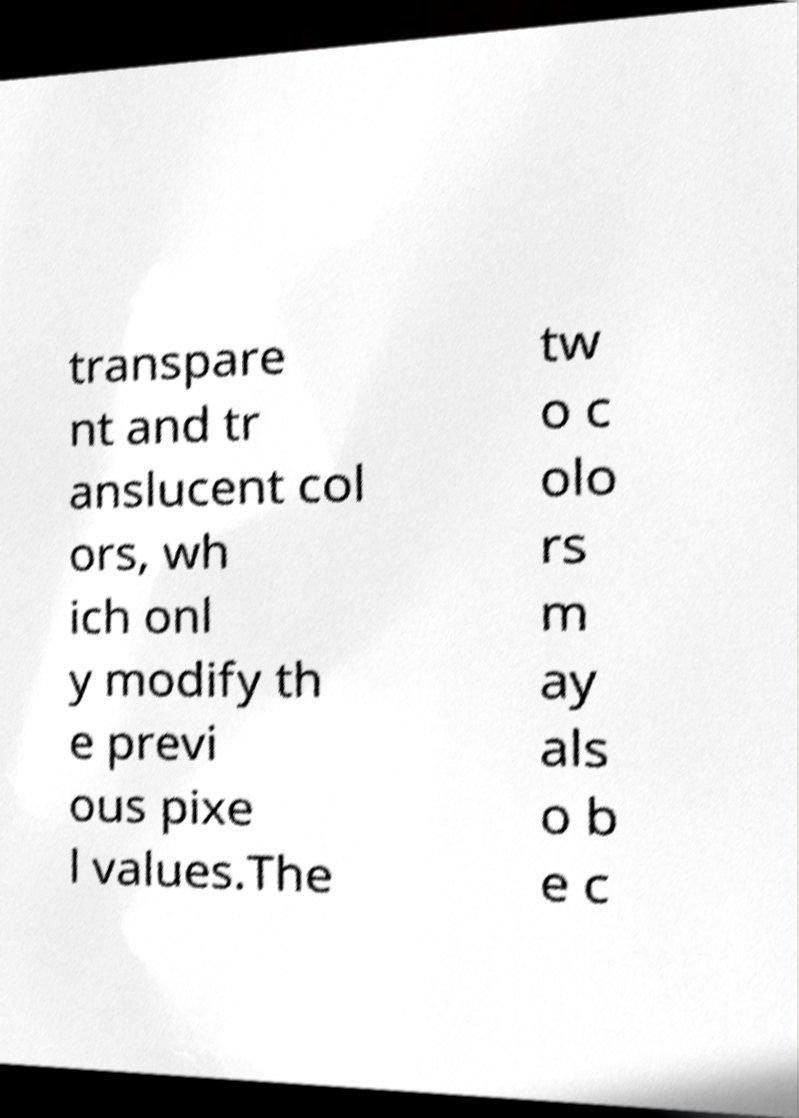I need the written content from this picture converted into text. Can you do that? transpare nt and tr anslucent col ors, wh ich onl y modify th e previ ous pixe l values.The tw o c olo rs m ay als o b e c 